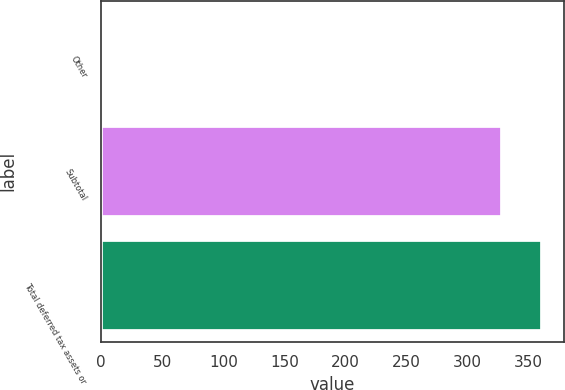<chart> <loc_0><loc_0><loc_500><loc_500><bar_chart><fcel>Other<fcel>Subtotal<fcel>Total deferred tax assets or<nl><fcel>1<fcel>328<fcel>360.7<nl></chart> 